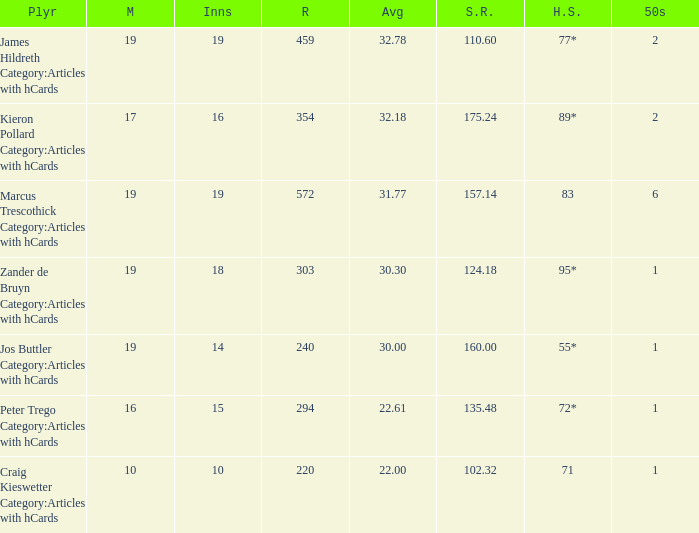What is the highest score for the player with average of 30.00? 55*. 